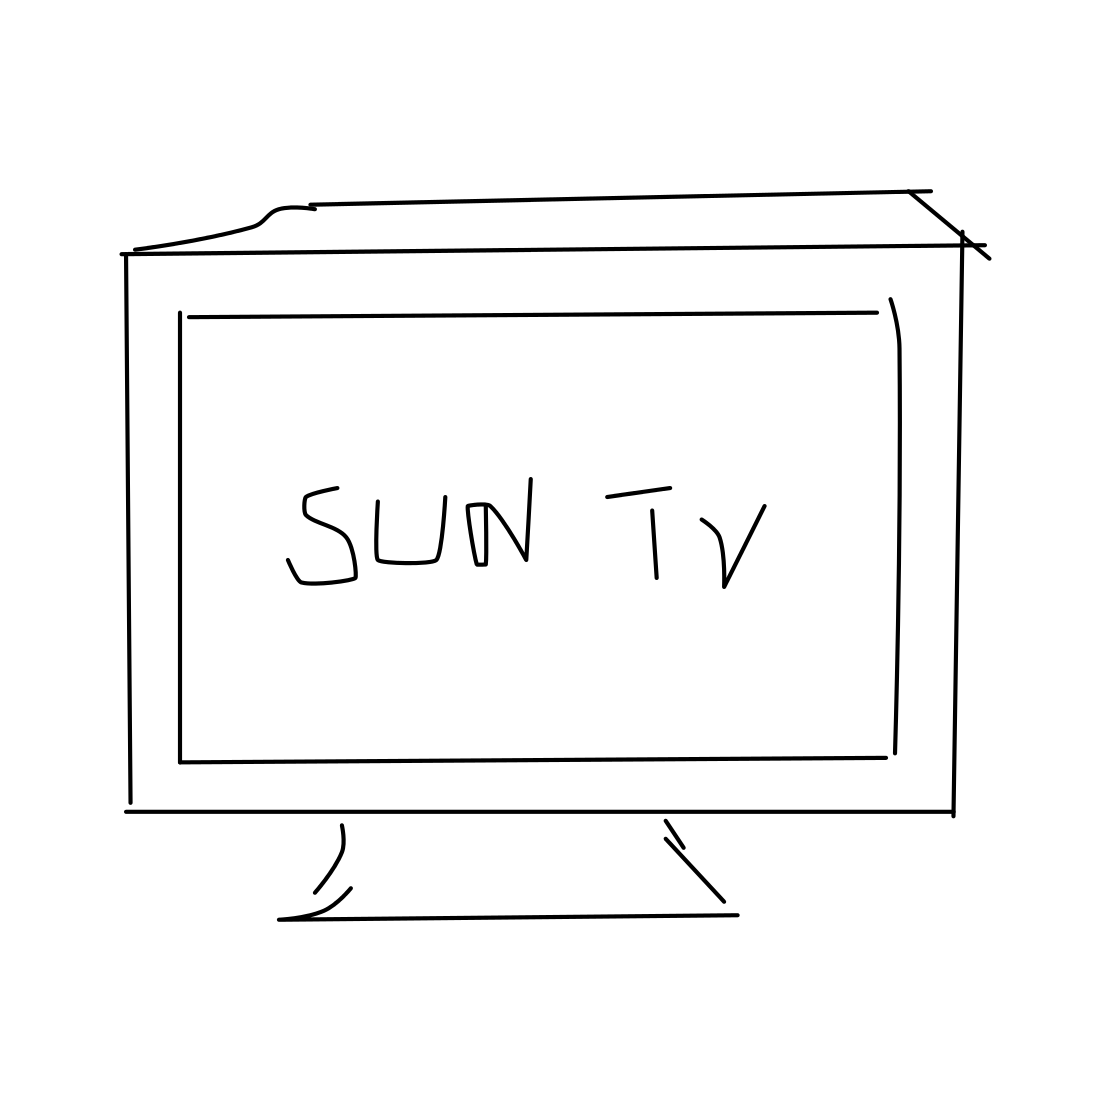Is there any indication of the era or technology of the TV depicted? The image does not provide specific details that would indicate the era or technology of the television set. Its simplicity omits characteristics such as buttons, screens, or inputs that could give away its vintage or modernity. Could this image be used as a logo? Absolutely, its simplicity and clear symbolization of a TV would make it suitable for use as a logo, especially for brands or services related to television or media. 